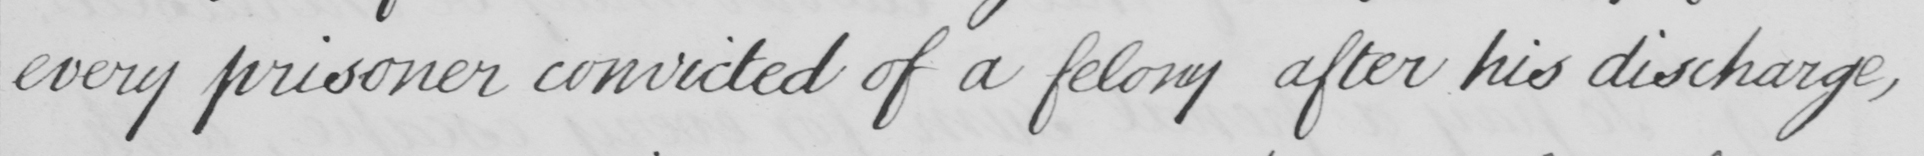What text is written in this handwritten line? every prisoner convicted of a felony after his discharge , 